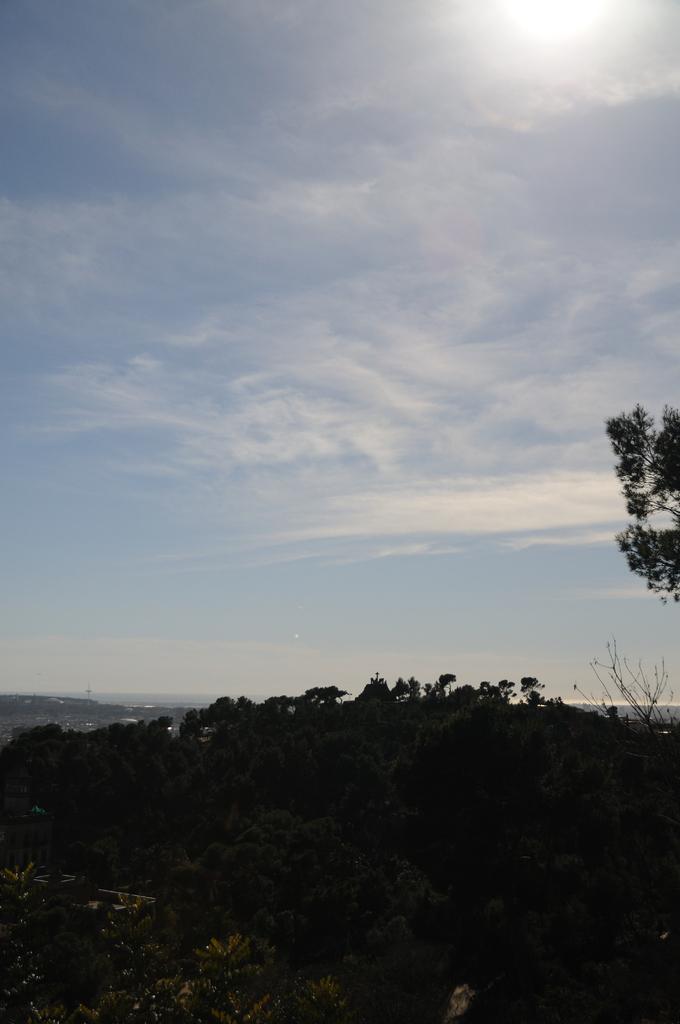How would you summarize this image in a sentence or two? In this image we can see so many plants. The sky is in blue color with some clouds and sun is there on the top of the image. 